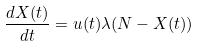<formula> <loc_0><loc_0><loc_500><loc_500>\frac { d X ( t ) } { d t } = u ( t ) \lambda ( N - X ( t ) )</formula> 